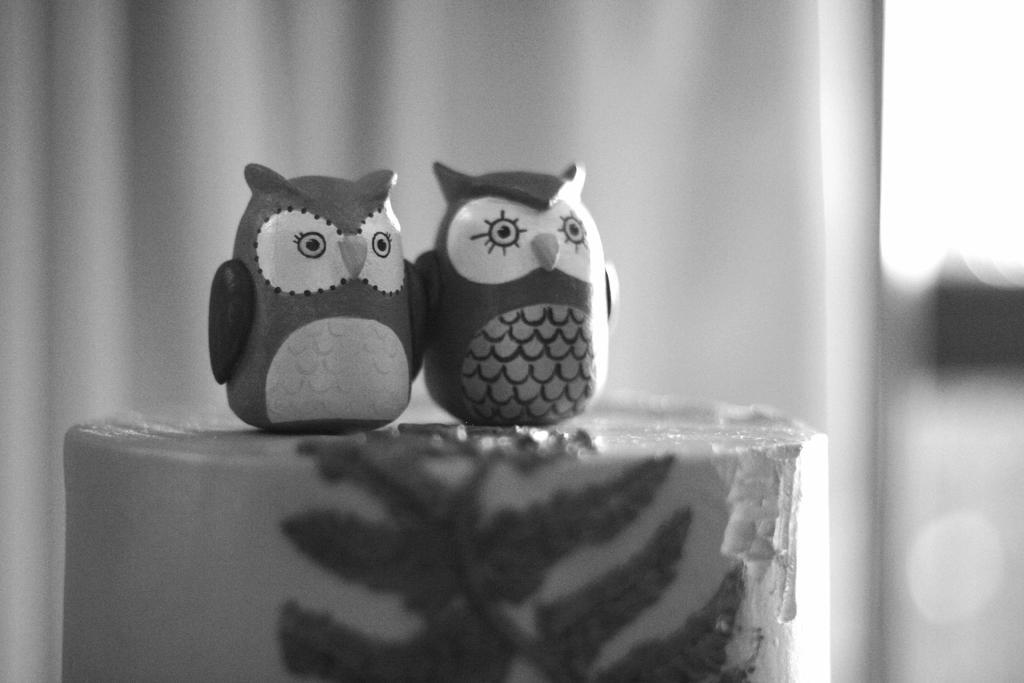How would you summarize this image in a sentence or two? This is a black and white image. There are 2 owl toys. The background is blurred. 